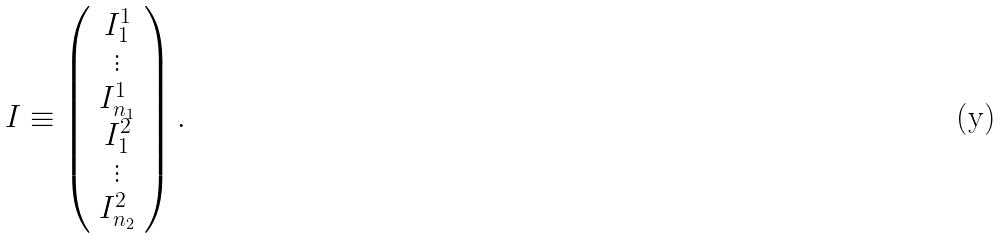Convert formula to latex. <formula><loc_0><loc_0><loc_500><loc_500>I \equiv \left ( \begin{array} { c } { { I _ { 1 } ^ { 1 } } } \\ { \vdots } \\ { { I _ { n _ { 1 } } ^ { 1 } } } \\ { { I _ { 1 } ^ { 2 } } } \\ { \vdots } \\ { { I _ { n _ { 2 } } ^ { 2 } } } \end{array} \right ) .</formula> 